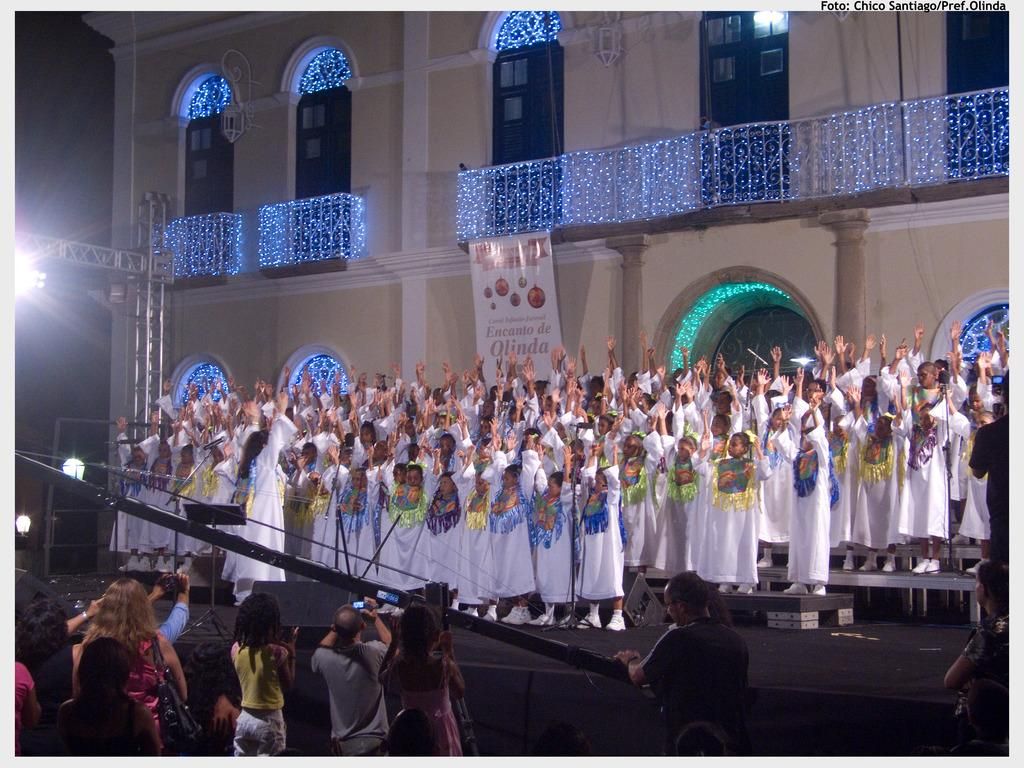What is happening in the image involving a group of people? There is a group of people standing in the image. What can be seen in the image that might be related to sound? There are speakers in the image. What type of signage is present in the image? There is a banner in the image. What structure is visible in the image that might be used for hanging lights or other equipment? There is a lighting truss in the image. What can be seen in the background of the image that might indicate the location or setting? There is a wall with windows in the background of the image. How does the thrill of the event affect the size of the leg in the image? There is no mention of a leg or an event in the image, so it is not possible to answer this question. 